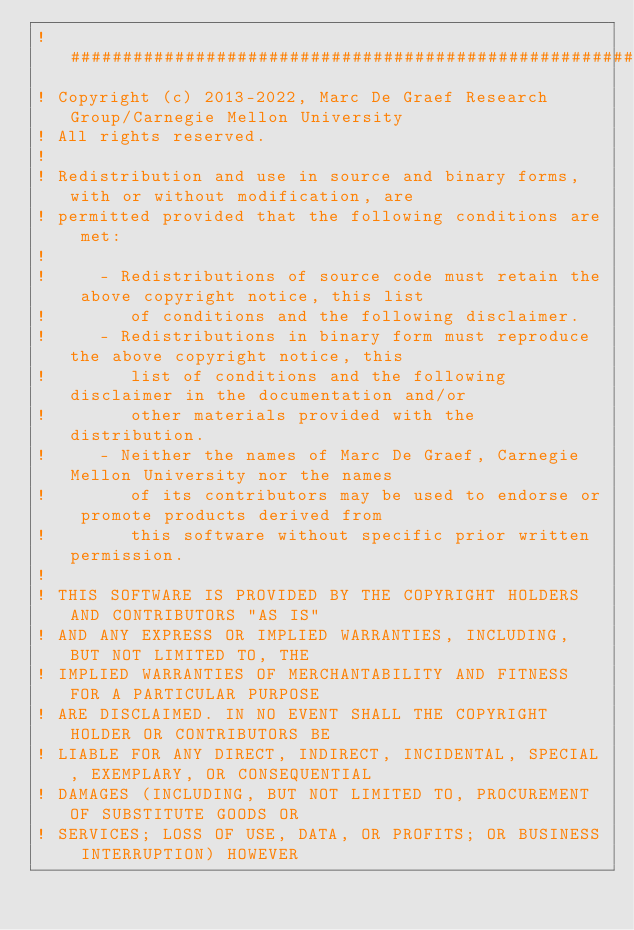Convert code to text. <code><loc_0><loc_0><loc_500><loc_500><_FORTRAN_>! ###################################################################
! Copyright (c) 2013-2022, Marc De Graef Research Group/Carnegie Mellon University
! All rights reserved.
!
! Redistribution and use in source and binary forms, with or without modification, are
! permitted provided that the following conditions are met:
!
!     - Redistributions of source code must retain the above copyright notice, this list
!        of conditions and the following disclaimer.
!     - Redistributions in binary form must reproduce the above copyright notice, this
!        list of conditions and the following disclaimer in the documentation and/or
!        other materials provided with the distribution.
!     - Neither the names of Marc De Graef, Carnegie Mellon University nor the names
!        of its contributors may be used to endorse or promote products derived from
!        this software without specific prior written permission.
!
! THIS SOFTWARE IS PROVIDED BY THE COPYRIGHT HOLDERS AND CONTRIBUTORS "AS IS"
! AND ANY EXPRESS OR IMPLIED WARRANTIES, INCLUDING, BUT NOT LIMITED TO, THE
! IMPLIED WARRANTIES OF MERCHANTABILITY AND FITNESS FOR A PARTICULAR PURPOSE
! ARE DISCLAIMED. IN NO EVENT SHALL THE COPYRIGHT HOLDER OR CONTRIBUTORS BE
! LIABLE FOR ANY DIRECT, INDIRECT, INCIDENTAL, SPECIAL, EXEMPLARY, OR CONSEQUENTIAL
! DAMAGES (INCLUDING, BUT NOT LIMITED TO, PROCUREMENT OF SUBSTITUTE GOODS OR
! SERVICES; LOSS OF USE, DATA, OR PROFITS; OR BUSINESS INTERRUPTION) HOWEVER</code> 